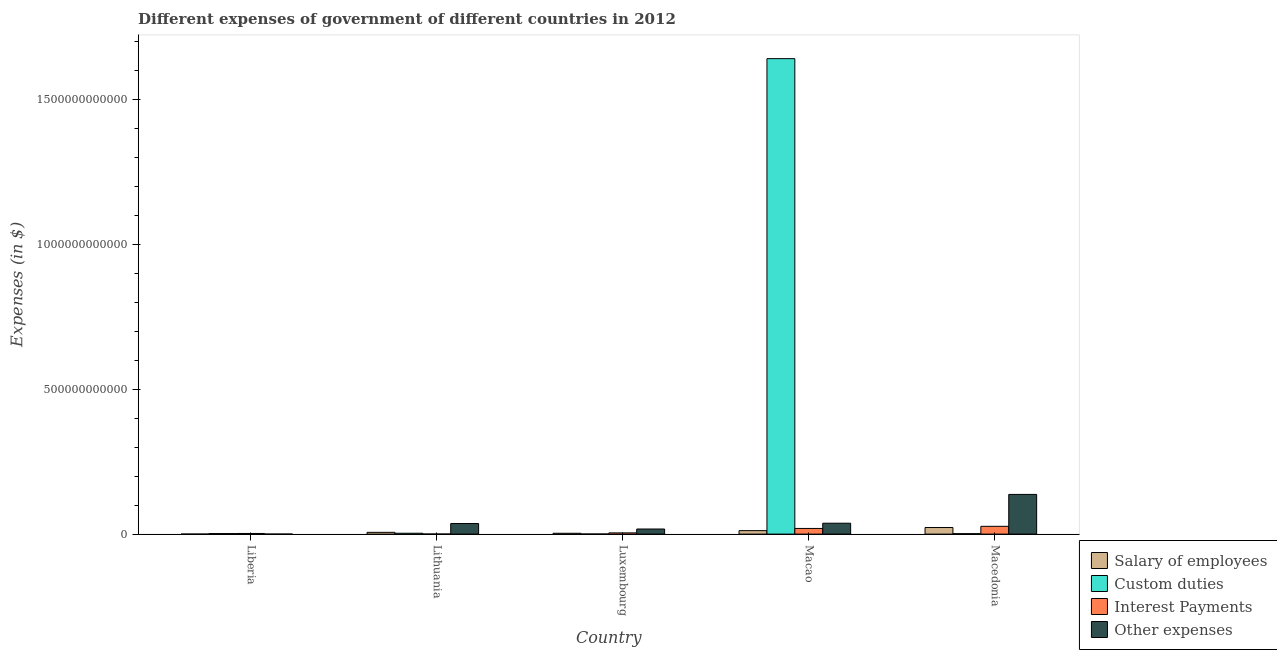How many different coloured bars are there?
Provide a succinct answer. 4. What is the label of the 1st group of bars from the left?
Your response must be concise. Liberia. In how many cases, is the number of bars for a given country not equal to the number of legend labels?
Offer a very short reply. 0. What is the amount spent on other expenses in Macedonia?
Your response must be concise. 1.37e+11. Across all countries, what is the maximum amount spent on other expenses?
Give a very brief answer. 1.37e+11. Across all countries, what is the minimum amount spent on custom duties?
Your response must be concise. 2.50e+08. In which country was the amount spent on salary of employees maximum?
Offer a terse response. Macedonia. In which country was the amount spent on other expenses minimum?
Give a very brief answer. Liberia. What is the total amount spent on salary of employees in the graph?
Your answer should be very brief. 4.36e+1. What is the difference between the amount spent on other expenses in Lithuania and that in Macao?
Provide a short and direct response. -1.09e+09. What is the difference between the amount spent on salary of employees in Lithuania and the amount spent on custom duties in Liberia?
Keep it short and to the point. 4.26e+09. What is the average amount spent on interest payments per country?
Offer a terse response. 1.06e+1. What is the difference between the amount spent on custom duties and amount spent on salary of employees in Lithuania?
Provide a succinct answer. -3.12e+09. In how many countries, is the amount spent on interest payments greater than 700000000000 $?
Your answer should be compact. 0. What is the ratio of the amount spent on salary of employees in Lithuania to that in Macao?
Your response must be concise. 0.51. Is the amount spent on other expenses in Luxembourg less than that in Macedonia?
Provide a short and direct response. Yes. What is the difference between the highest and the second highest amount spent on interest payments?
Keep it short and to the point. 7.35e+09. What is the difference between the highest and the lowest amount spent on custom duties?
Your answer should be very brief. 1.64e+12. In how many countries, is the amount spent on custom duties greater than the average amount spent on custom duties taken over all countries?
Keep it short and to the point. 1. Is it the case that in every country, the sum of the amount spent on other expenses and amount spent on interest payments is greater than the sum of amount spent on custom duties and amount spent on salary of employees?
Ensure brevity in your answer.  No. What does the 1st bar from the left in Lithuania represents?
Keep it short and to the point. Salary of employees. What does the 4th bar from the right in Macao represents?
Offer a terse response. Salary of employees. Is it the case that in every country, the sum of the amount spent on salary of employees and amount spent on custom duties is greater than the amount spent on interest payments?
Your response must be concise. No. Are all the bars in the graph horizontal?
Your response must be concise. No. What is the difference between two consecutive major ticks on the Y-axis?
Your answer should be very brief. 5.00e+11. Are the values on the major ticks of Y-axis written in scientific E-notation?
Provide a short and direct response. No. Does the graph contain any zero values?
Make the answer very short. No. Does the graph contain grids?
Give a very brief answer. No. Where does the legend appear in the graph?
Give a very brief answer. Bottom right. How many legend labels are there?
Provide a short and direct response. 4. How are the legend labels stacked?
Offer a terse response. Vertical. What is the title of the graph?
Provide a short and direct response. Different expenses of government of different countries in 2012. Does "Australia" appear as one of the legend labels in the graph?
Your response must be concise. No. What is the label or title of the Y-axis?
Your answer should be compact. Expenses (in $). What is the Expenses (in $) of Salary of employees in Liberia?
Give a very brief answer. 2.47e+06. What is the Expenses (in $) of Custom duties in Liberia?
Provide a succinct answer. 1.82e+09. What is the Expenses (in $) in Interest Payments in Liberia?
Give a very brief answer. 2.16e+09. What is the Expenses (in $) in Other expenses in Liberia?
Offer a terse response. 5.86e+06. What is the Expenses (in $) in Salary of employees in Lithuania?
Your answer should be very brief. 6.08e+09. What is the Expenses (in $) of Custom duties in Lithuania?
Keep it short and to the point. 2.96e+09. What is the Expenses (in $) in Interest Payments in Lithuania?
Offer a terse response. 1.96e+08. What is the Expenses (in $) of Other expenses in Lithuania?
Provide a short and direct response. 3.65e+1. What is the Expenses (in $) in Salary of employees in Luxembourg?
Keep it short and to the point. 2.84e+09. What is the Expenses (in $) of Custom duties in Luxembourg?
Your answer should be very brief. 2.50e+08. What is the Expenses (in $) of Interest Payments in Luxembourg?
Ensure brevity in your answer.  4.22e+09. What is the Expenses (in $) in Other expenses in Luxembourg?
Provide a succinct answer. 1.76e+1. What is the Expenses (in $) of Salary of employees in Macao?
Your answer should be compact. 1.19e+1. What is the Expenses (in $) in Custom duties in Macao?
Offer a terse response. 1.64e+12. What is the Expenses (in $) in Interest Payments in Macao?
Give a very brief answer. 1.95e+1. What is the Expenses (in $) in Other expenses in Macao?
Ensure brevity in your answer.  3.76e+1. What is the Expenses (in $) of Salary of employees in Macedonia?
Make the answer very short. 2.27e+1. What is the Expenses (in $) in Custom duties in Macedonia?
Ensure brevity in your answer.  1.53e+09. What is the Expenses (in $) in Interest Payments in Macedonia?
Keep it short and to the point. 2.69e+1. What is the Expenses (in $) of Other expenses in Macedonia?
Give a very brief answer. 1.37e+11. Across all countries, what is the maximum Expenses (in $) in Salary of employees?
Make the answer very short. 2.27e+1. Across all countries, what is the maximum Expenses (in $) of Custom duties?
Provide a short and direct response. 1.64e+12. Across all countries, what is the maximum Expenses (in $) of Interest Payments?
Provide a short and direct response. 2.69e+1. Across all countries, what is the maximum Expenses (in $) in Other expenses?
Ensure brevity in your answer.  1.37e+11. Across all countries, what is the minimum Expenses (in $) in Salary of employees?
Provide a short and direct response. 2.47e+06. Across all countries, what is the minimum Expenses (in $) of Custom duties?
Give a very brief answer. 2.50e+08. Across all countries, what is the minimum Expenses (in $) of Interest Payments?
Make the answer very short. 1.96e+08. Across all countries, what is the minimum Expenses (in $) in Other expenses?
Offer a terse response. 5.86e+06. What is the total Expenses (in $) of Salary of employees in the graph?
Your answer should be compact. 4.36e+1. What is the total Expenses (in $) in Custom duties in the graph?
Provide a short and direct response. 1.65e+12. What is the total Expenses (in $) in Interest Payments in the graph?
Keep it short and to the point. 5.30e+1. What is the total Expenses (in $) in Other expenses in the graph?
Give a very brief answer. 2.29e+11. What is the difference between the Expenses (in $) in Salary of employees in Liberia and that in Lithuania?
Your answer should be very brief. -6.08e+09. What is the difference between the Expenses (in $) of Custom duties in Liberia and that in Lithuania?
Provide a short and direct response. -1.14e+09. What is the difference between the Expenses (in $) in Interest Payments in Liberia and that in Lithuania?
Your response must be concise. 1.96e+09. What is the difference between the Expenses (in $) of Other expenses in Liberia and that in Lithuania?
Provide a short and direct response. -3.65e+1. What is the difference between the Expenses (in $) of Salary of employees in Liberia and that in Luxembourg?
Make the answer very short. -2.84e+09. What is the difference between the Expenses (in $) of Custom duties in Liberia and that in Luxembourg?
Provide a short and direct response. 1.57e+09. What is the difference between the Expenses (in $) in Interest Payments in Liberia and that in Luxembourg?
Keep it short and to the point. -2.06e+09. What is the difference between the Expenses (in $) of Other expenses in Liberia and that in Luxembourg?
Make the answer very short. -1.76e+1. What is the difference between the Expenses (in $) of Salary of employees in Liberia and that in Macao?
Keep it short and to the point. -1.19e+1. What is the difference between the Expenses (in $) of Custom duties in Liberia and that in Macao?
Ensure brevity in your answer.  -1.64e+12. What is the difference between the Expenses (in $) in Interest Payments in Liberia and that in Macao?
Provide a short and direct response. -1.74e+1. What is the difference between the Expenses (in $) of Other expenses in Liberia and that in Macao?
Provide a succinct answer. -3.76e+1. What is the difference between the Expenses (in $) in Salary of employees in Liberia and that in Macedonia?
Give a very brief answer. -2.27e+1. What is the difference between the Expenses (in $) of Custom duties in Liberia and that in Macedonia?
Offer a very short reply. 2.90e+08. What is the difference between the Expenses (in $) in Interest Payments in Liberia and that in Macedonia?
Your answer should be compact. -2.47e+1. What is the difference between the Expenses (in $) of Other expenses in Liberia and that in Macedonia?
Provide a succinct answer. -1.37e+11. What is the difference between the Expenses (in $) of Salary of employees in Lithuania and that in Luxembourg?
Make the answer very short. 3.23e+09. What is the difference between the Expenses (in $) of Custom duties in Lithuania and that in Luxembourg?
Your answer should be very brief. 2.71e+09. What is the difference between the Expenses (in $) in Interest Payments in Lithuania and that in Luxembourg?
Your response must be concise. -4.02e+09. What is the difference between the Expenses (in $) of Other expenses in Lithuania and that in Luxembourg?
Your answer should be compact. 1.90e+1. What is the difference between the Expenses (in $) in Salary of employees in Lithuania and that in Macao?
Keep it short and to the point. -5.87e+09. What is the difference between the Expenses (in $) of Custom duties in Lithuania and that in Macao?
Offer a terse response. -1.64e+12. What is the difference between the Expenses (in $) of Interest Payments in Lithuania and that in Macao?
Provide a succinct answer. -1.93e+1. What is the difference between the Expenses (in $) of Other expenses in Lithuania and that in Macao?
Make the answer very short. -1.09e+09. What is the difference between the Expenses (in $) in Salary of employees in Lithuania and that in Macedonia?
Provide a succinct answer. -1.66e+1. What is the difference between the Expenses (in $) in Custom duties in Lithuania and that in Macedonia?
Keep it short and to the point. 1.43e+09. What is the difference between the Expenses (in $) of Interest Payments in Lithuania and that in Macedonia?
Provide a succinct answer. -2.67e+1. What is the difference between the Expenses (in $) in Other expenses in Lithuania and that in Macedonia?
Your answer should be very brief. -1.01e+11. What is the difference between the Expenses (in $) in Salary of employees in Luxembourg and that in Macao?
Keep it short and to the point. -9.10e+09. What is the difference between the Expenses (in $) of Custom duties in Luxembourg and that in Macao?
Provide a succinct answer. -1.64e+12. What is the difference between the Expenses (in $) in Interest Payments in Luxembourg and that in Macao?
Keep it short and to the point. -1.53e+1. What is the difference between the Expenses (in $) of Other expenses in Luxembourg and that in Macao?
Make the answer very short. -2.00e+1. What is the difference between the Expenses (in $) in Salary of employees in Luxembourg and that in Macedonia?
Your response must be concise. -1.99e+1. What is the difference between the Expenses (in $) of Custom duties in Luxembourg and that in Macedonia?
Provide a succinct answer. -1.28e+09. What is the difference between the Expenses (in $) of Interest Payments in Luxembourg and that in Macedonia?
Your response must be concise. -2.27e+1. What is the difference between the Expenses (in $) in Other expenses in Luxembourg and that in Macedonia?
Make the answer very short. -1.20e+11. What is the difference between the Expenses (in $) in Salary of employees in Macao and that in Macedonia?
Your answer should be very brief. -1.08e+1. What is the difference between the Expenses (in $) of Custom duties in Macao and that in Macedonia?
Give a very brief answer. 1.64e+12. What is the difference between the Expenses (in $) in Interest Payments in Macao and that in Macedonia?
Provide a short and direct response. -7.35e+09. What is the difference between the Expenses (in $) in Other expenses in Macao and that in Macedonia?
Offer a terse response. -9.95e+1. What is the difference between the Expenses (in $) in Salary of employees in Liberia and the Expenses (in $) in Custom duties in Lithuania?
Keep it short and to the point. -2.96e+09. What is the difference between the Expenses (in $) of Salary of employees in Liberia and the Expenses (in $) of Interest Payments in Lithuania?
Provide a short and direct response. -1.94e+08. What is the difference between the Expenses (in $) of Salary of employees in Liberia and the Expenses (in $) of Other expenses in Lithuania?
Your response must be concise. -3.65e+1. What is the difference between the Expenses (in $) in Custom duties in Liberia and the Expenses (in $) in Interest Payments in Lithuania?
Make the answer very short. 1.62e+09. What is the difference between the Expenses (in $) of Custom duties in Liberia and the Expenses (in $) of Other expenses in Lithuania?
Ensure brevity in your answer.  -3.47e+1. What is the difference between the Expenses (in $) in Interest Payments in Liberia and the Expenses (in $) in Other expenses in Lithuania?
Your answer should be very brief. -3.44e+1. What is the difference between the Expenses (in $) in Salary of employees in Liberia and the Expenses (in $) in Custom duties in Luxembourg?
Your response must be concise. -2.48e+08. What is the difference between the Expenses (in $) of Salary of employees in Liberia and the Expenses (in $) of Interest Payments in Luxembourg?
Ensure brevity in your answer.  -4.21e+09. What is the difference between the Expenses (in $) of Salary of employees in Liberia and the Expenses (in $) of Other expenses in Luxembourg?
Make the answer very short. -1.76e+1. What is the difference between the Expenses (in $) in Custom duties in Liberia and the Expenses (in $) in Interest Payments in Luxembourg?
Ensure brevity in your answer.  -2.40e+09. What is the difference between the Expenses (in $) in Custom duties in Liberia and the Expenses (in $) in Other expenses in Luxembourg?
Your response must be concise. -1.58e+1. What is the difference between the Expenses (in $) in Interest Payments in Liberia and the Expenses (in $) in Other expenses in Luxembourg?
Provide a succinct answer. -1.54e+1. What is the difference between the Expenses (in $) in Salary of employees in Liberia and the Expenses (in $) in Custom duties in Macao?
Make the answer very short. -1.64e+12. What is the difference between the Expenses (in $) in Salary of employees in Liberia and the Expenses (in $) in Interest Payments in Macao?
Keep it short and to the point. -1.95e+1. What is the difference between the Expenses (in $) of Salary of employees in Liberia and the Expenses (in $) of Other expenses in Macao?
Offer a terse response. -3.76e+1. What is the difference between the Expenses (in $) in Custom duties in Liberia and the Expenses (in $) in Interest Payments in Macao?
Give a very brief answer. -1.77e+1. What is the difference between the Expenses (in $) of Custom duties in Liberia and the Expenses (in $) of Other expenses in Macao?
Offer a terse response. -3.58e+1. What is the difference between the Expenses (in $) of Interest Payments in Liberia and the Expenses (in $) of Other expenses in Macao?
Make the answer very short. -3.55e+1. What is the difference between the Expenses (in $) of Salary of employees in Liberia and the Expenses (in $) of Custom duties in Macedonia?
Offer a very short reply. -1.52e+09. What is the difference between the Expenses (in $) in Salary of employees in Liberia and the Expenses (in $) in Interest Payments in Macedonia?
Make the answer very short. -2.69e+1. What is the difference between the Expenses (in $) of Salary of employees in Liberia and the Expenses (in $) of Other expenses in Macedonia?
Provide a short and direct response. -1.37e+11. What is the difference between the Expenses (in $) of Custom duties in Liberia and the Expenses (in $) of Interest Payments in Macedonia?
Offer a terse response. -2.51e+1. What is the difference between the Expenses (in $) in Custom duties in Liberia and the Expenses (in $) in Other expenses in Macedonia?
Give a very brief answer. -1.35e+11. What is the difference between the Expenses (in $) of Interest Payments in Liberia and the Expenses (in $) of Other expenses in Macedonia?
Make the answer very short. -1.35e+11. What is the difference between the Expenses (in $) in Salary of employees in Lithuania and the Expenses (in $) in Custom duties in Luxembourg?
Make the answer very short. 5.83e+09. What is the difference between the Expenses (in $) of Salary of employees in Lithuania and the Expenses (in $) of Interest Payments in Luxembourg?
Make the answer very short. 1.86e+09. What is the difference between the Expenses (in $) in Salary of employees in Lithuania and the Expenses (in $) in Other expenses in Luxembourg?
Ensure brevity in your answer.  -1.15e+1. What is the difference between the Expenses (in $) in Custom duties in Lithuania and the Expenses (in $) in Interest Payments in Luxembourg?
Offer a very short reply. -1.26e+09. What is the difference between the Expenses (in $) in Custom duties in Lithuania and the Expenses (in $) in Other expenses in Luxembourg?
Offer a very short reply. -1.46e+1. What is the difference between the Expenses (in $) of Interest Payments in Lithuania and the Expenses (in $) of Other expenses in Luxembourg?
Offer a terse response. -1.74e+1. What is the difference between the Expenses (in $) in Salary of employees in Lithuania and the Expenses (in $) in Custom duties in Macao?
Offer a terse response. -1.64e+12. What is the difference between the Expenses (in $) of Salary of employees in Lithuania and the Expenses (in $) of Interest Payments in Macao?
Your answer should be very brief. -1.35e+1. What is the difference between the Expenses (in $) in Salary of employees in Lithuania and the Expenses (in $) in Other expenses in Macao?
Provide a short and direct response. -3.16e+1. What is the difference between the Expenses (in $) of Custom duties in Lithuania and the Expenses (in $) of Interest Payments in Macao?
Offer a terse response. -1.66e+1. What is the difference between the Expenses (in $) in Custom duties in Lithuania and the Expenses (in $) in Other expenses in Macao?
Your answer should be very brief. -3.47e+1. What is the difference between the Expenses (in $) in Interest Payments in Lithuania and the Expenses (in $) in Other expenses in Macao?
Provide a short and direct response. -3.74e+1. What is the difference between the Expenses (in $) in Salary of employees in Lithuania and the Expenses (in $) in Custom duties in Macedonia?
Offer a terse response. 4.55e+09. What is the difference between the Expenses (in $) of Salary of employees in Lithuania and the Expenses (in $) of Interest Payments in Macedonia?
Ensure brevity in your answer.  -2.08e+1. What is the difference between the Expenses (in $) of Salary of employees in Lithuania and the Expenses (in $) of Other expenses in Macedonia?
Provide a succinct answer. -1.31e+11. What is the difference between the Expenses (in $) in Custom duties in Lithuania and the Expenses (in $) in Interest Payments in Macedonia?
Provide a succinct answer. -2.39e+1. What is the difference between the Expenses (in $) in Custom duties in Lithuania and the Expenses (in $) in Other expenses in Macedonia?
Your answer should be very brief. -1.34e+11. What is the difference between the Expenses (in $) in Interest Payments in Lithuania and the Expenses (in $) in Other expenses in Macedonia?
Your answer should be very brief. -1.37e+11. What is the difference between the Expenses (in $) of Salary of employees in Luxembourg and the Expenses (in $) of Custom duties in Macao?
Offer a terse response. -1.64e+12. What is the difference between the Expenses (in $) of Salary of employees in Luxembourg and the Expenses (in $) of Interest Payments in Macao?
Your answer should be very brief. -1.67e+1. What is the difference between the Expenses (in $) of Salary of employees in Luxembourg and the Expenses (in $) of Other expenses in Macao?
Ensure brevity in your answer.  -3.48e+1. What is the difference between the Expenses (in $) in Custom duties in Luxembourg and the Expenses (in $) in Interest Payments in Macao?
Your answer should be very brief. -1.93e+1. What is the difference between the Expenses (in $) in Custom duties in Luxembourg and the Expenses (in $) in Other expenses in Macao?
Ensure brevity in your answer.  -3.74e+1. What is the difference between the Expenses (in $) of Interest Payments in Luxembourg and the Expenses (in $) of Other expenses in Macao?
Provide a short and direct response. -3.34e+1. What is the difference between the Expenses (in $) in Salary of employees in Luxembourg and the Expenses (in $) in Custom duties in Macedonia?
Your answer should be compact. 1.32e+09. What is the difference between the Expenses (in $) of Salary of employees in Luxembourg and the Expenses (in $) of Interest Payments in Macedonia?
Give a very brief answer. -2.40e+1. What is the difference between the Expenses (in $) of Salary of employees in Luxembourg and the Expenses (in $) of Other expenses in Macedonia?
Provide a short and direct response. -1.34e+11. What is the difference between the Expenses (in $) of Custom duties in Luxembourg and the Expenses (in $) of Interest Payments in Macedonia?
Give a very brief answer. -2.66e+1. What is the difference between the Expenses (in $) in Custom duties in Luxembourg and the Expenses (in $) in Other expenses in Macedonia?
Ensure brevity in your answer.  -1.37e+11. What is the difference between the Expenses (in $) in Interest Payments in Luxembourg and the Expenses (in $) in Other expenses in Macedonia?
Give a very brief answer. -1.33e+11. What is the difference between the Expenses (in $) in Salary of employees in Macao and the Expenses (in $) in Custom duties in Macedonia?
Your answer should be very brief. 1.04e+1. What is the difference between the Expenses (in $) of Salary of employees in Macao and the Expenses (in $) of Interest Payments in Macedonia?
Offer a terse response. -1.49e+1. What is the difference between the Expenses (in $) in Salary of employees in Macao and the Expenses (in $) in Other expenses in Macedonia?
Keep it short and to the point. -1.25e+11. What is the difference between the Expenses (in $) in Custom duties in Macao and the Expenses (in $) in Interest Payments in Macedonia?
Provide a short and direct response. 1.62e+12. What is the difference between the Expenses (in $) in Custom duties in Macao and the Expenses (in $) in Other expenses in Macedonia?
Your response must be concise. 1.50e+12. What is the difference between the Expenses (in $) in Interest Payments in Macao and the Expenses (in $) in Other expenses in Macedonia?
Your response must be concise. -1.18e+11. What is the average Expenses (in $) in Salary of employees per country?
Offer a very short reply. 8.72e+09. What is the average Expenses (in $) in Custom duties per country?
Give a very brief answer. 3.30e+11. What is the average Expenses (in $) in Interest Payments per country?
Your answer should be compact. 1.06e+1. What is the average Expenses (in $) of Other expenses per country?
Offer a very short reply. 4.58e+1. What is the difference between the Expenses (in $) of Salary of employees and Expenses (in $) of Custom duties in Liberia?
Your answer should be compact. -1.81e+09. What is the difference between the Expenses (in $) in Salary of employees and Expenses (in $) in Interest Payments in Liberia?
Provide a succinct answer. -2.16e+09. What is the difference between the Expenses (in $) in Salary of employees and Expenses (in $) in Other expenses in Liberia?
Give a very brief answer. -3.39e+06. What is the difference between the Expenses (in $) in Custom duties and Expenses (in $) in Interest Payments in Liberia?
Your answer should be compact. -3.42e+08. What is the difference between the Expenses (in $) of Custom duties and Expenses (in $) of Other expenses in Liberia?
Keep it short and to the point. 1.81e+09. What is the difference between the Expenses (in $) of Interest Payments and Expenses (in $) of Other expenses in Liberia?
Give a very brief answer. 2.15e+09. What is the difference between the Expenses (in $) in Salary of employees and Expenses (in $) in Custom duties in Lithuania?
Ensure brevity in your answer.  3.12e+09. What is the difference between the Expenses (in $) in Salary of employees and Expenses (in $) in Interest Payments in Lithuania?
Make the answer very short. 5.88e+09. What is the difference between the Expenses (in $) of Salary of employees and Expenses (in $) of Other expenses in Lithuania?
Offer a terse response. -3.05e+1. What is the difference between the Expenses (in $) of Custom duties and Expenses (in $) of Interest Payments in Lithuania?
Give a very brief answer. 2.76e+09. What is the difference between the Expenses (in $) of Custom duties and Expenses (in $) of Other expenses in Lithuania?
Ensure brevity in your answer.  -3.36e+1. What is the difference between the Expenses (in $) in Interest Payments and Expenses (in $) in Other expenses in Lithuania?
Your answer should be compact. -3.63e+1. What is the difference between the Expenses (in $) of Salary of employees and Expenses (in $) of Custom duties in Luxembourg?
Ensure brevity in your answer.  2.59e+09. What is the difference between the Expenses (in $) of Salary of employees and Expenses (in $) of Interest Payments in Luxembourg?
Give a very brief answer. -1.37e+09. What is the difference between the Expenses (in $) of Salary of employees and Expenses (in $) of Other expenses in Luxembourg?
Ensure brevity in your answer.  -1.47e+1. What is the difference between the Expenses (in $) in Custom duties and Expenses (in $) in Interest Payments in Luxembourg?
Give a very brief answer. -3.97e+09. What is the difference between the Expenses (in $) in Custom duties and Expenses (in $) in Other expenses in Luxembourg?
Give a very brief answer. -1.73e+1. What is the difference between the Expenses (in $) of Interest Payments and Expenses (in $) of Other expenses in Luxembourg?
Ensure brevity in your answer.  -1.34e+1. What is the difference between the Expenses (in $) in Salary of employees and Expenses (in $) in Custom duties in Macao?
Your answer should be compact. -1.63e+12. What is the difference between the Expenses (in $) of Salary of employees and Expenses (in $) of Interest Payments in Macao?
Give a very brief answer. -7.59e+09. What is the difference between the Expenses (in $) of Salary of employees and Expenses (in $) of Other expenses in Macao?
Keep it short and to the point. -2.57e+1. What is the difference between the Expenses (in $) in Custom duties and Expenses (in $) in Interest Payments in Macao?
Keep it short and to the point. 1.62e+12. What is the difference between the Expenses (in $) of Custom duties and Expenses (in $) of Other expenses in Macao?
Your answer should be very brief. 1.60e+12. What is the difference between the Expenses (in $) in Interest Payments and Expenses (in $) in Other expenses in Macao?
Offer a terse response. -1.81e+1. What is the difference between the Expenses (in $) in Salary of employees and Expenses (in $) in Custom duties in Macedonia?
Your answer should be compact. 2.12e+1. What is the difference between the Expenses (in $) in Salary of employees and Expenses (in $) in Interest Payments in Macedonia?
Provide a short and direct response. -4.18e+09. What is the difference between the Expenses (in $) of Salary of employees and Expenses (in $) of Other expenses in Macedonia?
Your answer should be very brief. -1.14e+11. What is the difference between the Expenses (in $) of Custom duties and Expenses (in $) of Interest Payments in Macedonia?
Give a very brief answer. -2.54e+1. What is the difference between the Expenses (in $) in Custom duties and Expenses (in $) in Other expenses in Macedonia?
Provide a succinct answer. -1.36e+11. What is the difference between the Expenses (in $) of Interest Payments and Expenses (in $) of Other expenses in Macedonia?
Provide a short and direct response. -1.10e+11. What is the ratio of the Expenses (in $) in Salary of employees in Liberia to that in Lithuania?
Provide a short and direct response. 0. What is the ratio of the Expenses (in $) of Custom duties in Liberia to that in Lithuania?
Your response must be concise. 0.61. What is the ratio of the Expenses (in $) in Interest Payments in Liberia to that in Lithuania?
Offer a very short reply. 10.99. What is the ratio of the Expenses (in $) of Salary of employees in Liberia to that in Luxembourg?
Offer a very short reply. 0. What is the ratio of the Expenses (in $) in Custom duties in Liberia to that in Luxembourg?
Give a very brief answer. 7.26. What is the ratio of the Expenses (in $) in Interest Payments in Liberia to that in Luxembourg?
Provide a short and direct response. 0.51. What is the ratio of the Expenses (in $) in Salary of employees in Liberia to that in Macao?
Ensure brevity in your answer.  0. What is the ratio of the Expenses (in $) in Custom duties in Liberia to that in Macao?
Your response must be concise. 0. What is the ratio of the Expenses (in $) of Interest Payments in Liberia to that in Macao?
Make the answer very short. 0.11. What is the ratio of the Expenses (in $) in Custom duties in Liberia to that in Macedonia?
Your response must be concise. 1.19. What is the ratio of the Expenses (in $) in Interest Payments in Liberia to that in Macedonia?
Your response must be concise. 0.08. What is the ratio of the Expenses (in $) in Salary of employees in Lithuania to that in Luxembourg?
Provide a short and direct response. 2.14. What is the ratio of the Expenses (in $) in Custom duties in Lithuania to that in Luxembourg?
Ensure brevity in your answer.  11.84. What is the ratio of the Expenses (in $) in Interest Payments in Lithuania to that in Luxembourg?
Your answer should be compact. 0.05. What is the ratio of the Expenses (in $) in Other expenses in Lithuania to that in Luxembourg?
Give a very brief answer. 2.08. What is the ratio of the Expenses (in $) in Salary of employees in Lithuania to that in Macao?
Offer a very short reply. 0.51. What is the ratio of the Expenses (in $) of Custom duties in Lithuania to that in Macao?
Your answer should be compact. 0. What is the ratio of the Expenses (in $) of Interest Payments in Lithuania to that in Macao?
Keep it short and to the point. 0.01. What is the ratio of the Expenses (in $) of Other expenses in Lithuania to that in Macao?
Provide a short and direct response. 0.97. What is the ratio of the Expenses (in $) in Salary of employees in Lithuania to that in Macedonia?
Give a very brief answer. 0.27. What is the ratio of the Expenses (in $) of Custom duties in Lithuania to that in Macedonia?
Give a very brief answer. 1.94. What is the ratio of the Expenses (in $) in Interest Payments in Lithuania to that in Macedonia?
Offer a terse response. 0.01. What is the ratio of the Expenses (in $) of Other expenses in Lithuania to that in Macedonia?
Offer a terse response. 0.27. What is the ratio of the Expenses (in $) of Salary of employees in Luxembourg to that in Macao?
Provide a short and direct response. 0.24. What is the ratio of the Expenses (in $) of Interest Payments in Luxembourg to that in Macao?
Keep it short and to the point. 0.22. What is the ratio of the Expenses (in $) in Other expenses in Luxembourg to that in Macao?
Offer a terse response. 0.47. What is the ratio of the Expenses (in $) of Salary of employees in Luxembourg to that in Macedonia?
Offer a terse response. 0.13. What is the ratio of the Expenses (in $) of Custom duties in Luxembourg to that in Macedonia?
Keep it short and to the point. 0.16. What is the ratio of the Expenses (in $) of Interest Payments in Luxembourg to that in Macedonia?
Your answer should be compact. 0.16. What is the ratio of the Expenses (in $) in Other expenses in Luxembourg to that in Macedonia?
Your answer should be very brief. 0.13. What is the ratio of the Expenses (in $) of Salary of employees in Macao to that in Macedonia?
Offer a terse response. 0.53. What is the ratio of the Expenses (in $) in Custom duties in Macao to that in Macedonia?
Provide a succinct answer. 1076.05. What is the ratio of the Expenses (in $) in Interest Payments in Macao to that in Macedonia?
Give a very brief answer. 0.73. What is the ratio of the Expenses (in $) in Other expenses in Macao to that in Macedonia?
Your answer should be very brief. 0.27. What is the difference between the highest and the second highest Expenses (in $) of Salary of employees?
Make the answer very short. 1.08e+1. What is the difference between the highest and the second highest Expenses (in $) of Custom duties?
Offer a very short reply. 1.64e+12. What is the difference between the highest and the second highest Expenses (in $) of Interest Payments?
Your response must be concise. 7.35e+09. What is the difference between the highest and the second highest Expenses (in $) of Other expenses?
Provide a short and direct response. 9.95e+1. What is the difference between the highest and the lowest Expenses (in $) in Salary of employees?
Provide a succinct answer. 2.27e+1. What is the difference between the highest and the lowest Expenses (in $) in Custom duties?
Offer a very short reply. 1.64e+12. What is the difference between the highest and the lowest Expenses (in $) of Interest Payments?
Offer a very short reply. 2.67e+1. What is the difference between the highest and the lowest Expenses (in $) in Other expenses?
Keep it short and to the point. 1.37e+11. 